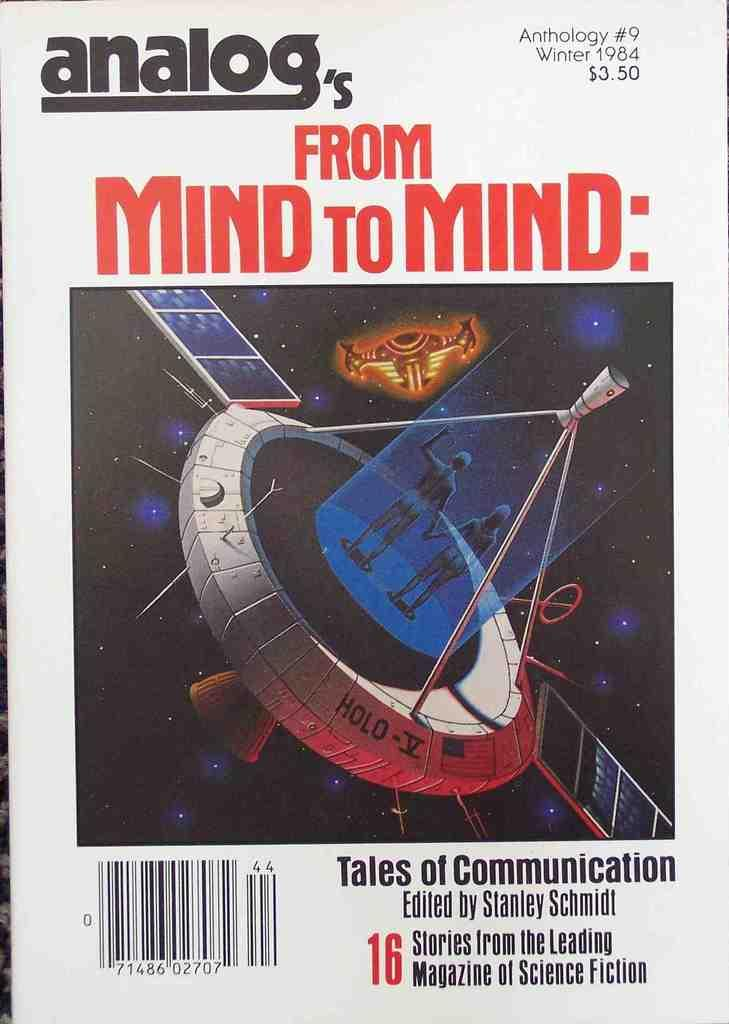<image>
Describe the image concisely. Cover that shows a spaceship and says "Tales of Communication" on the bottom. 